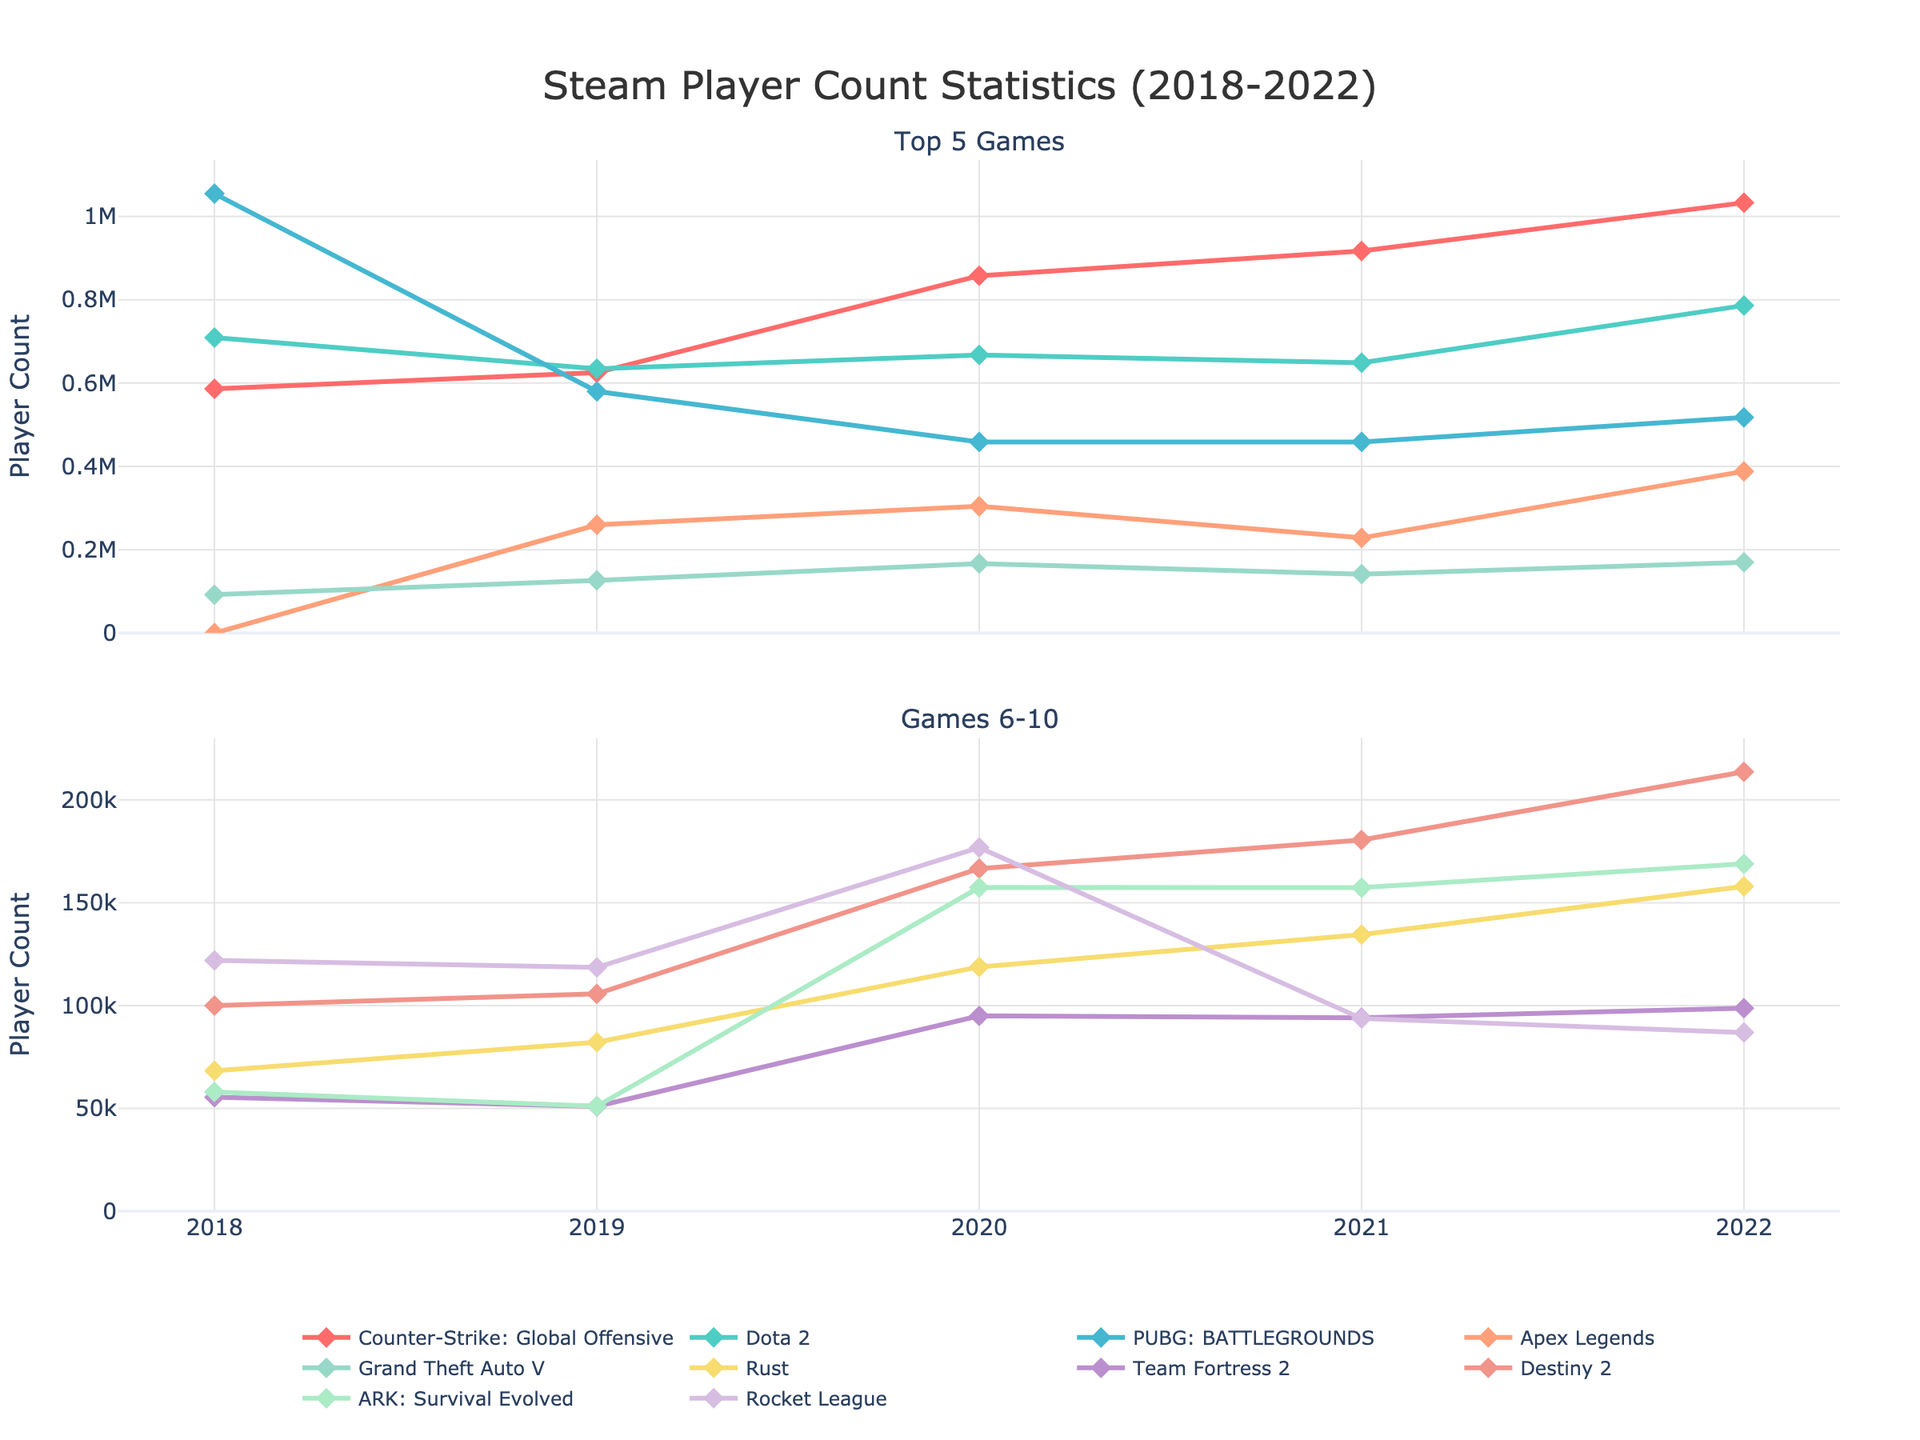Which game had the highest player count in 2018? The chart has two subplots. By looking at the top 5 games in the first subplot, Counter-Strike: Global Offensive, Dota 2, and PUBG are shown as the top players. The highest lines belong to PUBG in 2018.
Answer: PUBG: BATTLEGROUNDS Which games showed an increase in the player count every year from 2018 to 2022? By examining the lines, only Counter-Strike: Global Offensive shows a consistent increase in player count from 2018 to 2022.
Answer: Counter-Strike: Global Offensive Compare the player count of Dota 2 in 2018 with its player count in 2021. Was there an increase or decrease, and by how much? In 2018, Dota 2 had 709178 players, and in 2021, it had 648875. The difference is 709178 - 648875 = 60303, indicating a decrease.
Answer: Decrease by 60303 What is the average player count of Rocket League from 2018 to 2022? Summing the player count for Rocket League each year: 121952 + 118526 + 176820 + 93693 + 86882 = 577873. Dividing by the number of years (5) gives the average: 577873 / 5 = 115574.6
Answer: 115574.6 Which game out of the top 10 had the least number of players in 2019? By focusing on the numbers for 2019, Team Fortress 2 has the lowest player count with 50962.
Answer: Team Fortress 2 How did the Apex Legends player count change from 2020 to 2022? The Apex Legends player count in 2020 was 304226 and increased to 388147 in 2022. The change is 388147 - 304226 = 83921.
Answer: Increased by 83921 Compare the player counts of Rust and Destiny 2 in 2021. Which game had more players and by how much? The 2021 player count for Rust is 134483 and for Destiny 2 is 180483. Destiny 2 had 180483 - 134483 = 46000 more players.
Answer: Destiny 2 by 46000 Which game had the most fluctuating (highest range) player count over the five years? To find the game with the highest range, calculate the difference between the highest and lowest player counts for each game. PUBG had the most fluctuation, ranging from 1054650 in 2018 to 458675 in 2020. The difference is 1054650 - 458675 = 596975.
Answer: PUBG: BATTLEGROUNDS Among the top 5 games, which one saw the highest growth rate in player count from 2018 to 2022? Growth rate is calculated as (final value - initial value) / initial value. The player count for Counter-Strike: Global Offensive in 2018 was 586234 and in 2022 it was 1032971. The growth rate is (1032971 - 586234) / 586234 ≈ 0.761 or 76.1%.
Answer: Counter-Strike: Global Offensive with 76.1% 